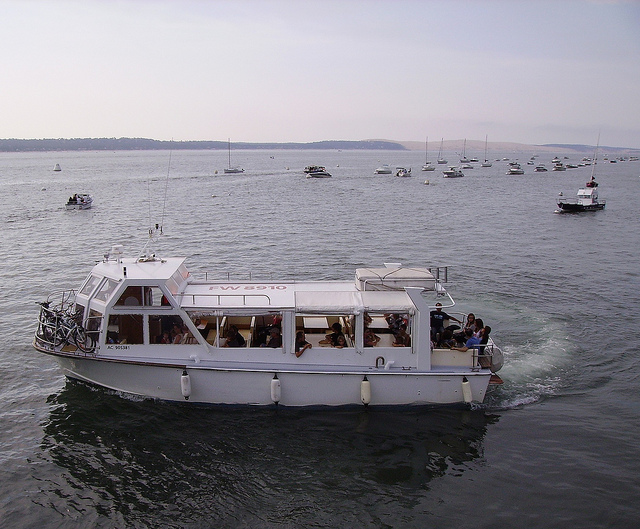Please identify all text content in this image. 8910 